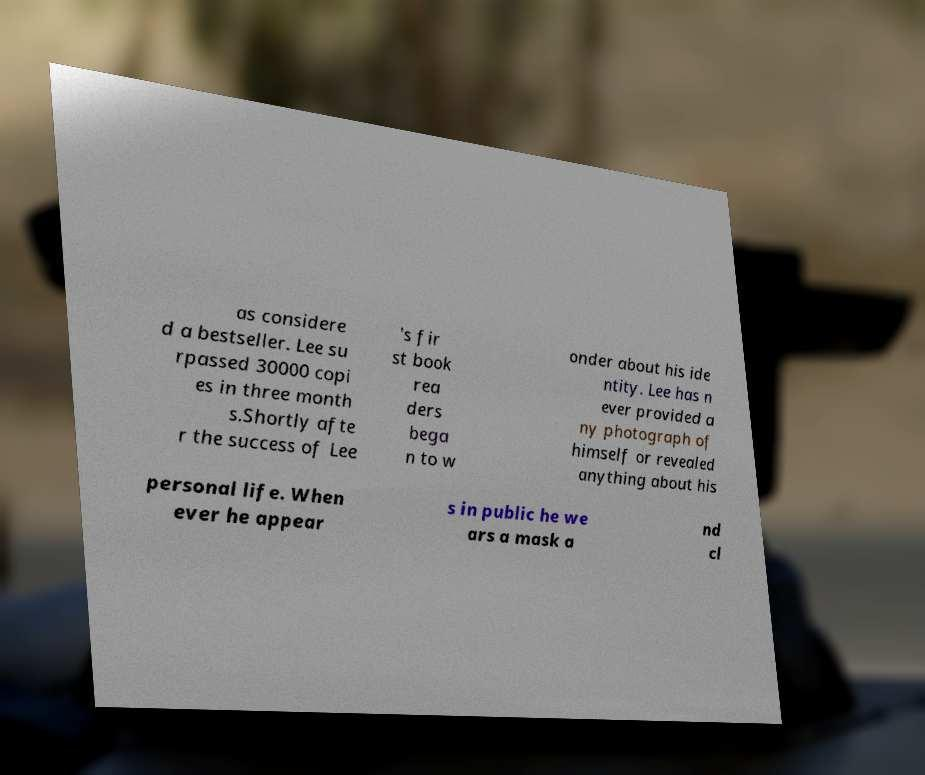There's text embedded in this image that I need extracted. Can you transcribe it verbatim? as considere d a bestseller. Lee su rpassed 30000 copi es in three month s.Shortly afte r the success of Lee 's fir st book rea ders bega n to w onder about his ide ntity. Lee has n ever provided a ny photograph of himself or revealed anything about his personal life. When ever he appear s in public he we ars a mask a nd cl 